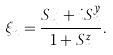<formula> <loc_0><loc_0><loc_500><loc_500>\xi _ { n } = \frac { S _ { n } ^ { x } + i S _ { n } ^ { y } } { 1 + S _ { n } ^ { z } } .</formula> 